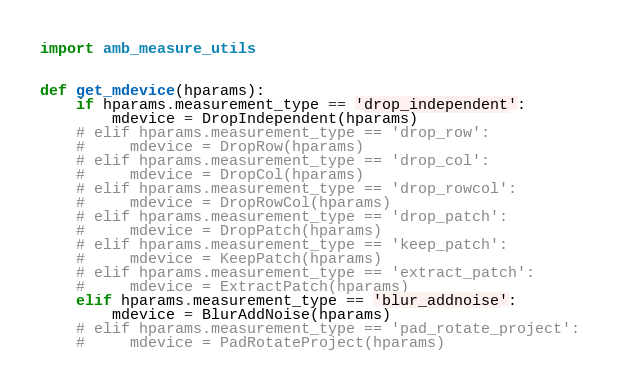<code> <loc_0><loc_0><loc_500><loc_500><_Python_>import amb_measure_utils


def get_mdevice(hparams):
    if hparams.measurement_type == 'drop_independent':
        mdevice = DropIndependent(hparams)
    # elif hparams.measurement_type == 'drop_row':
    #     mdevice = DropRow(hparams)
    # elif hparams.measurement_type == 'drop_col':
    #     mdevice = DropCol(hparams)
    # elif hparams.measurement_type == 'drop_rowcol':
    #     mdevice = DropRowCol(hparams)
    # elif hparams.measurement_type == 'drop_patch':
    #     mdevice = DropPatch(hparams)
    # elif hparams.measurement_type == 'keep_patch':
    #     mdevice = KeepPatch(hparams)
    # elif hparams.measurement_type == 'extract_patch':
    #     mdevice = ExtractPatch(hparams)
    elif hparams.measurement_type == 'blur_addnoise':
        mdevice = BlurAddNoise(hparams)
    # elif hparams.measurement_type == 'pad_rotate_project':
    #     mdevice = PadRotateProject(hparams)</code> 